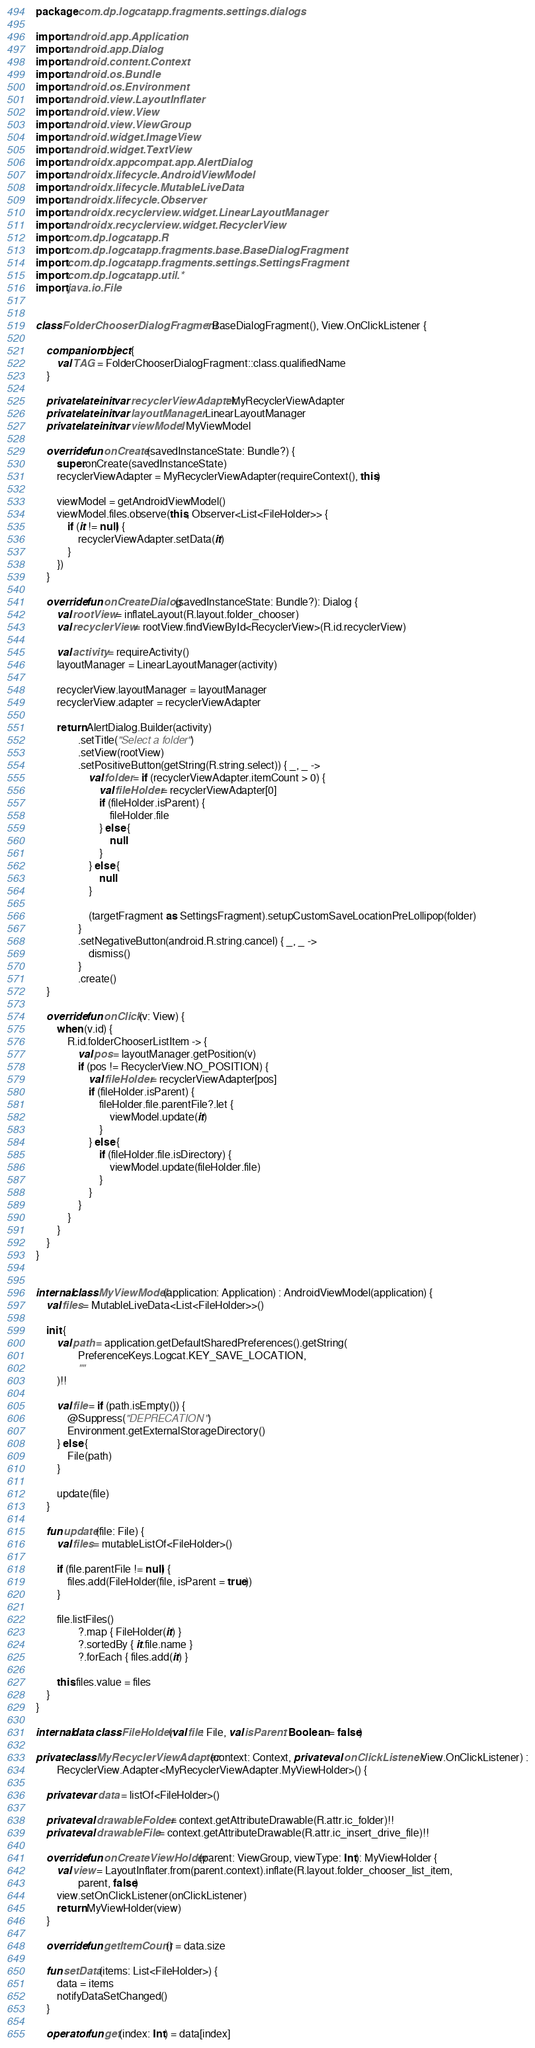<code> <loc_0><loc_0><loc_500><loc_500><_Kotlin_>package com.dp.logcatapp.fragments.settings.dialogs

import android.app.Application
import android.app.Dialog
import android.content.Context
import android.os.Bundle
import android.os.Environment
import android.view.LayoutInflater
import android.view.View
import android.view.ViewGroup
import android.widget.ImageView
import android.widget.TextView
import androidx.appcompat.app.AlertDialog
import androidx.lifecycle.AndroidViewModel
import androidx.lifecycle.MutableLiveData
import androidx.lifecycle.Observer
import androidx.recyclerview.widget.LinearLayoutManager
import androidx.recyclerview.widget.RecyclerView
import com.dp.logcatapp.R
import com.dp.logcatapp.fragments.base.BaseDialogFragment
import com.dp.logcatapp.fragments.settings.SettingsFragment
import com.dp.logcatapp.util.*
import java.io.File


class FolderChooserDialogFragment : BaseDialogFragment(), View.OnClickListener {

    companion object {
        val TAG = FolderChooserDialogFragment::class.qualifiedName
    }

    private lateinit var recyclerViewAdapter: MyRecyclerViewAdapter
    private lateinit var layoutManager: LinearLayoutManager
    private lateinit var viewModel: MyViewModel

    override fun onCreate(savedInstanceState: Bundle?) {
        super.onCreate(savedInstanceState)
        recyclerViewAdapter = MyRecyclerViewAdapter(requireContext(), this)

        viewModel = getAndroidViewModel()
        viewModel.files.observe(this, Observer<List<FileHolder>> {
            if (it != null) {
                recyclerViewAdapter.setData(it)
            }
        })
    }

    override fun onCreateDialog(savedInstanceState: Bundle?): Dialog {
        val rootView = inflateLayout(R.layout.folder_chooser)
        val recyclerView = rootView.findViewById<RecyclerView>(R.id.recyclerView)

        val activity = requireActivity()
        layoutManager = LinearLayoutManager(activity)

        recyclerView.layoutManager = layoutManager
        recyclerView.adapter = recyclerViewAdapter

        return AlertDialog.Builder(activity)
                .setTitle("Select a folder")
                .setView(rootView)
                .setPositiveButton(getString(R.string.select)) { _, _ ->
                    val folder = if (recyclerViewAdapter.itemCount > 0) {
                        val fileHolder = recyclerViewAdapter[0]
                        if (fileHolder.isParent) {
                            fileHolder.file
                        } else {
                            null
                        }
                    } else {
                        null
                    }

                    (targetFragment as SettingsFragment).setupCustomSaveLocationPreLollipop(folder)
                }
                .setNegativeButton(android.R.string.cancel) { _, _ ->
                    dismiss()
                }
                .create()
    }

    override fun onClick(v: View) {
        when (v.id) {
            R.id.folderChooserListItem -> {
                val pos = layoutManager.getPosition(v)
                if (pos != RecyclerView.NO_POSITION) {
                    val fileHolder = recyclerViewAdapter[pos]
                    if (fileHolder.isParent) {
                        fileHolder.file.parentFile?.let {
                            viewModel.update(it)
                        }
                    } else {
                        if (fileHolder.file.isDirectory) {
                            viewModel.update(fileHolder.file)
                        }
                    }
                }
            }
        }
    }
}


internal class MyViewModel(application: Application) : AndroidViewModel(application) {
    val files = MutableLiveData<List<FileHolder>>()

    init {
        val path = application.getDefaultSharedPreferences().getString(
                PreferenceKeys.Logcat.KEY_SAVE_LOCATION,
                ""
        )!!

        val file = if (path.isEmpty()) {
            @Suppress("DEPRECATION")
            Environment.getExternalStorageDirectory()
        } else {
            File(path)
        }

        update(file)
    }

    fun update(file: File) {
        val files = mutableListOf<FileHolder>()

        if (file.parentFile != null) {
            files.add(FileHolder(file, isParent = true))
        }

        file.listFiles()
                ?.map { FileHolder(it) }
                ?.sortedBy { it.file.name }
                ?.forEach { files.add(it) }

        this.files.value = files
    }
}

internal data class FileHolder(val file: File, val isParent: Boolean = false)

private class MyRecyclerViewAdapter(context: Context, private val onClickListener: View.OnClickListener) :
        RecyclerView.Adapter<MyRecyclerViewAdapter.MyViewHolder>() {

    private var data = listOf<FileHolder>()

    private val drawableFolder = context.getAttributeDrawable(R.attr.ic_folder)!!
    private val drawableFile = context.getAttributeDrawable(R.attr.ic_insert_drive_file)!!

    override fun onCreateViewHolder(parent: ViewGroup, viewType: Int): MyViewHolder {
        val view = LayoutInflater.from(parent.context).inflate(R.layout.folder_chooser_list_item,
                parent, false)
        view.setOnClickListener(onClickListener)
        return MyViewHolder(view)
    }

    override fun getItemCount() = data.size

    fun setData(items: List<FileHolder>) {
        data = items
        notifyDataSetChanged()
    }

    operator fun get(index: Int) = data[index]
</code> 